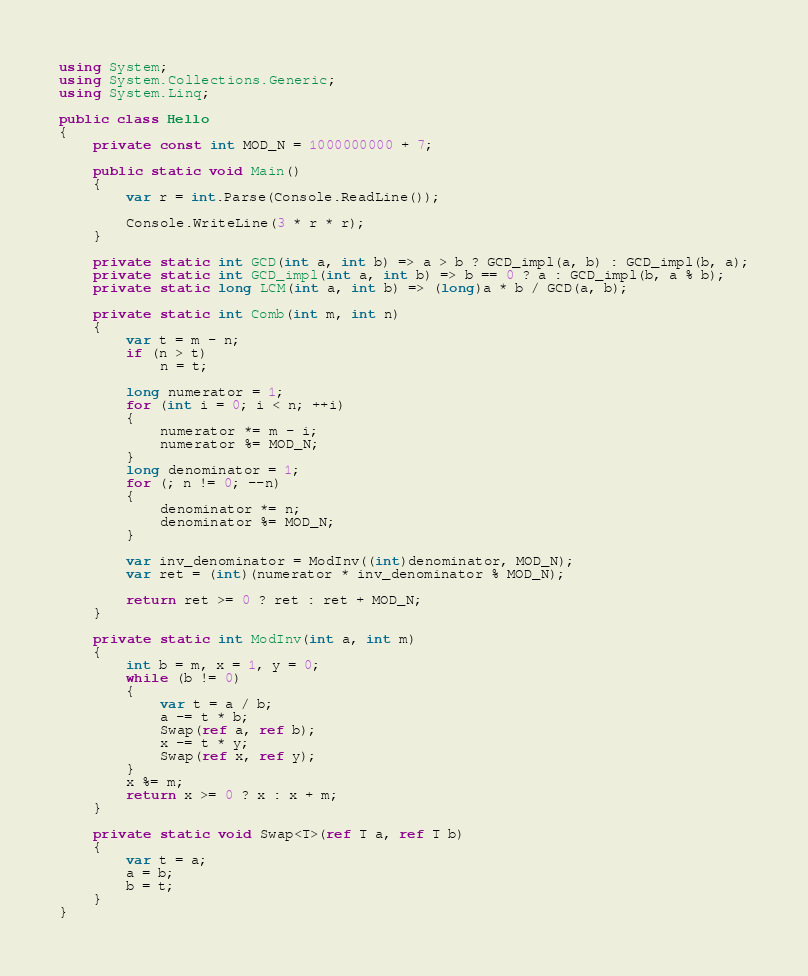<code> <loc_0><loc_0><loc_500><loc_500><_C#_>using System;
using System.Collections.Generic;
using System.Linq;

public class Hello
{
    private const int MOD_N = 1000000000 + 7;

    public static void Main()
    {
        var r = int.Parse(Console.ReadLine());

        Console.WriteLine(3 * r * r);
    }

    private static int GCD(int a, int b) => a > b ? GCD_impl(a, b) : GCD_impl(b, a);
    private static int GCD_impl(int a, int b) => b == 0 ? a : GCD_impl(b, a % b);
    private static long LCM(int a, int b) => (long)a * b / GCD(a, b);

    private static int Comb(int m, int n)
    {
        var t = m - n;
        if (n > t)
            n = t;

        long numerator = 1;
        for (int i = 0; i < n; ++i)
        {
            numerator *= m - i;
            numerator %= MOD_N;
        }
        long denominator = 1;
        for (; n != 0; --n)
        {
            denominator *= n;
            denominator %= MOD_N;
        }

        var inv_denominator = ModInv((int)denominator, MOD_N);
        var ret = (int)(numerator * inv_denominator % MOD_N);

        return ret >= 0 ? ret : ret + MOD_N;
    }

    private static int ModInv(int a, int m)
    {
        int b = m, x = 1, y = 0;
        while (b != 0)
        {
            var t = a / b;
            a -= t * b;
            Swap(ref a, ref b);
            x -= t * y;
            Swap(ref x, ref y);
        }
        x %= m;
        return x >= 0 ? x : x + m;
    }

    private static void Swap<T>(ref T a, ref T b)
    {
        var t = a;
        a = b;
        b = t;
    }
}
</code> 